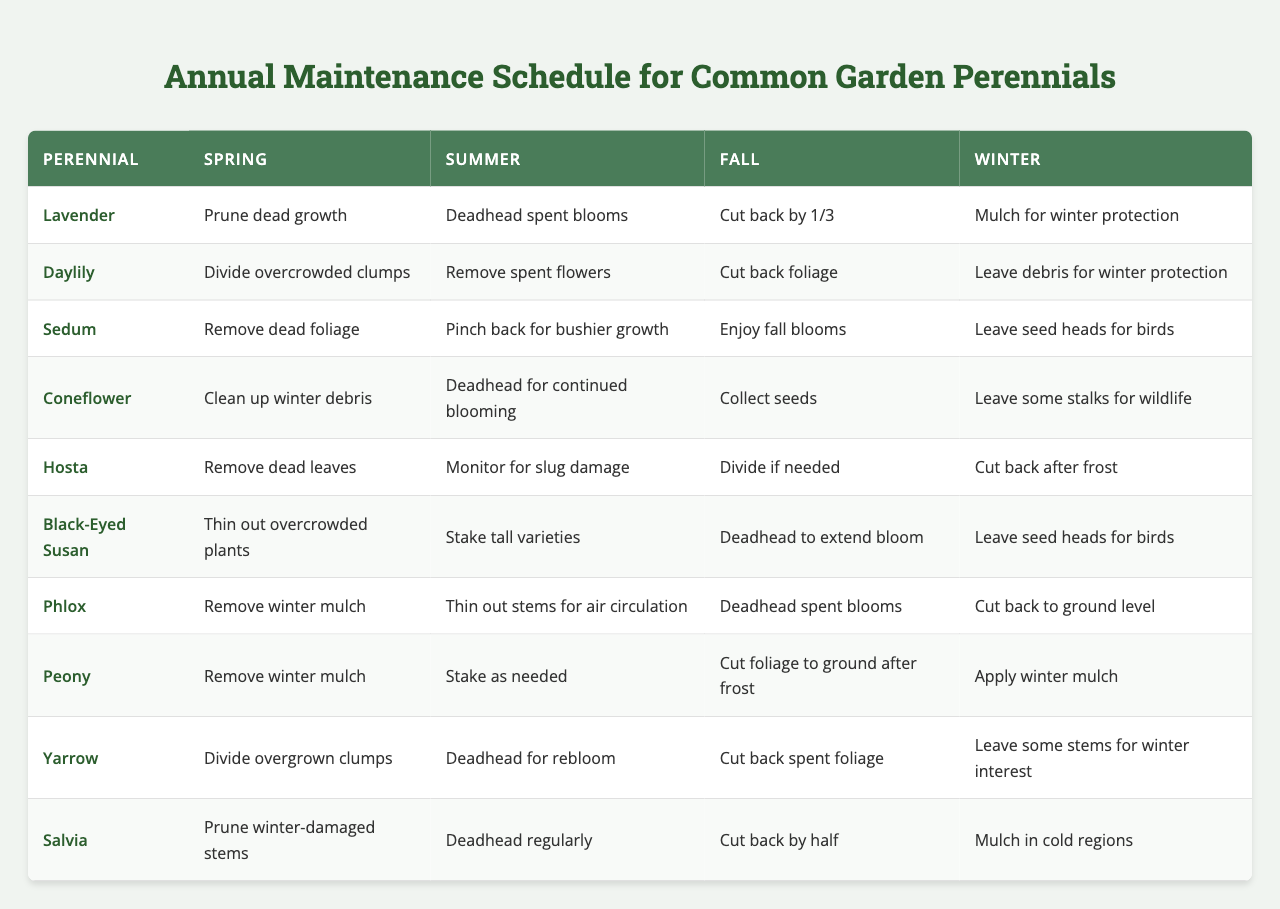What maintenance does Lavender need in the Fall? According to the table, Lavender needs to be cut back by one-third in the Fall.
Answer: Cut back by 1/3 Which plants require deadheading in the Summer? The table lists four plants requiring deadheading in the Summer: Coneflower, Black-Eyed Susan, Phlox, and Salvia.
Answer: Coneflower, Black-Eyed Susan, Phlox, Salvia Is it true that Hosta requires dividing in the Fall? The table indicates that Hosta only needs to be divided if needed in the Fall, but it does not explicitly state it requires dividing then. Thus, it is not true.
Answer: No Which two plants have a similar maintenance task in Spring regarding dead growth? Both Lavender and Salvia require pruning of dead growth in the Spring, which is similar maintenance.
Answer: Lavender and Salvia What is the main maintenance activity for Sedum during Summer and Fall? Sedum needs to be pinched back for bushier growth in Summer and enjoyed for fall blooms in Fall.
Answer: Pinch back in Summer; enjoy fall blooms in Fall How many plants require monitoring for damage during the growing season? There are two plants that require monitoring: Hosta for slug damage in Summer and none in the other seasons, making the total count one.
Answer: One plant Which plant allows for winter protection by leaving debris in Winter? The Daylily allows for winter protection by leaving debris in the Winter.
Answer: Daylily In which season should Black-Eyed Susan be thinned out? According to the table, Black-Eyed Susan should be thinned out during Spring.
Answer: Spring What is the unique maintenance task for Peony in Winter? In Winter, Peony requires applying winter mulch for protection, which is a unique task compared to other plants.
Answer: Apply winter mulch How does the maintenance of Yarrow in Summer differ from that of Coneflower? Yarrow requires deadheading for rebloom in Summer, while Coneflower requires deadheading for continued blooming, indicating a subtle difference in purpose.
Answer: Different purposes for deadheading 